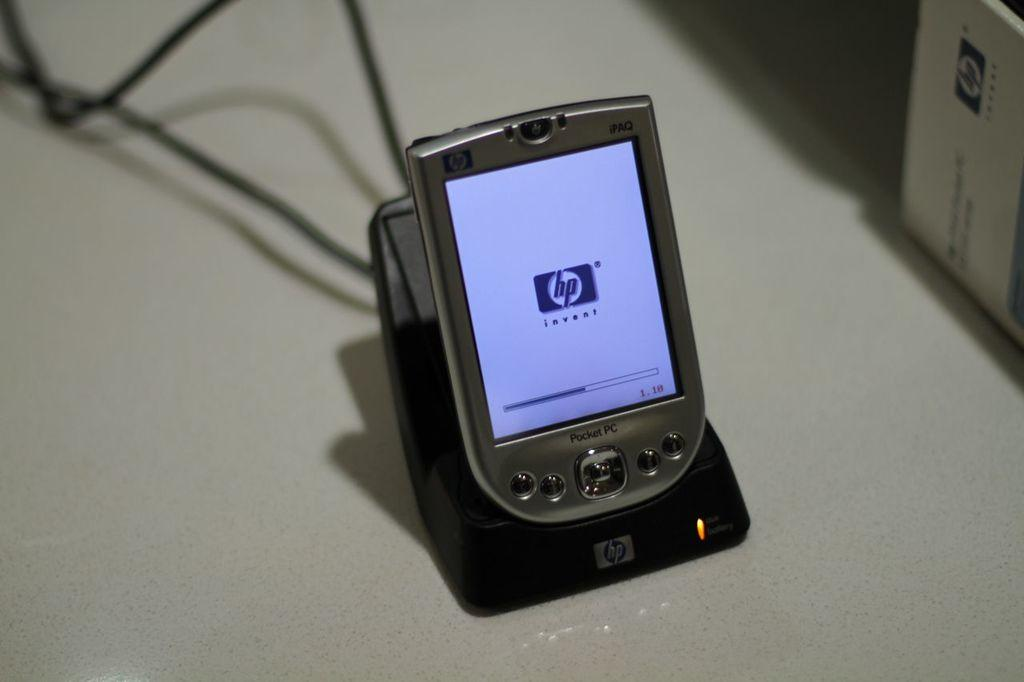<image>
Create a compact narrative representing the image presented. An hp electronic device sitting in a charger 